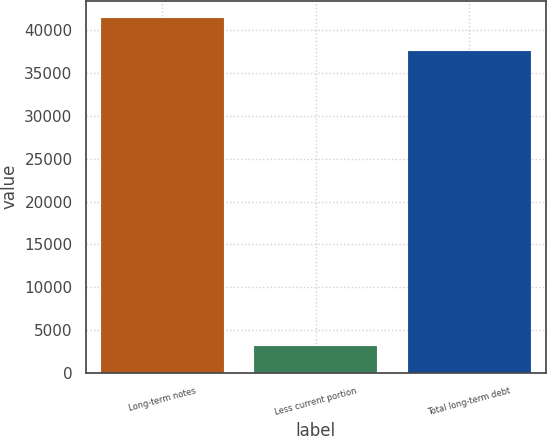Convert chart to OTSL. <chart><loc_0><loc_0><loc_500><loc_500><bar_chart><fcel>Long-term notes<fcel>Less current portion<fcel>Total long-term debt<nl><fcel>41398.5<fcel>3188<fcel>37635<nl></chart> 